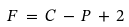Convert formula to latex. <formula><loc_0><loc_0><loc_500><loc_500>F \, = \, C \, - \, P \, + \, 2</formula> 